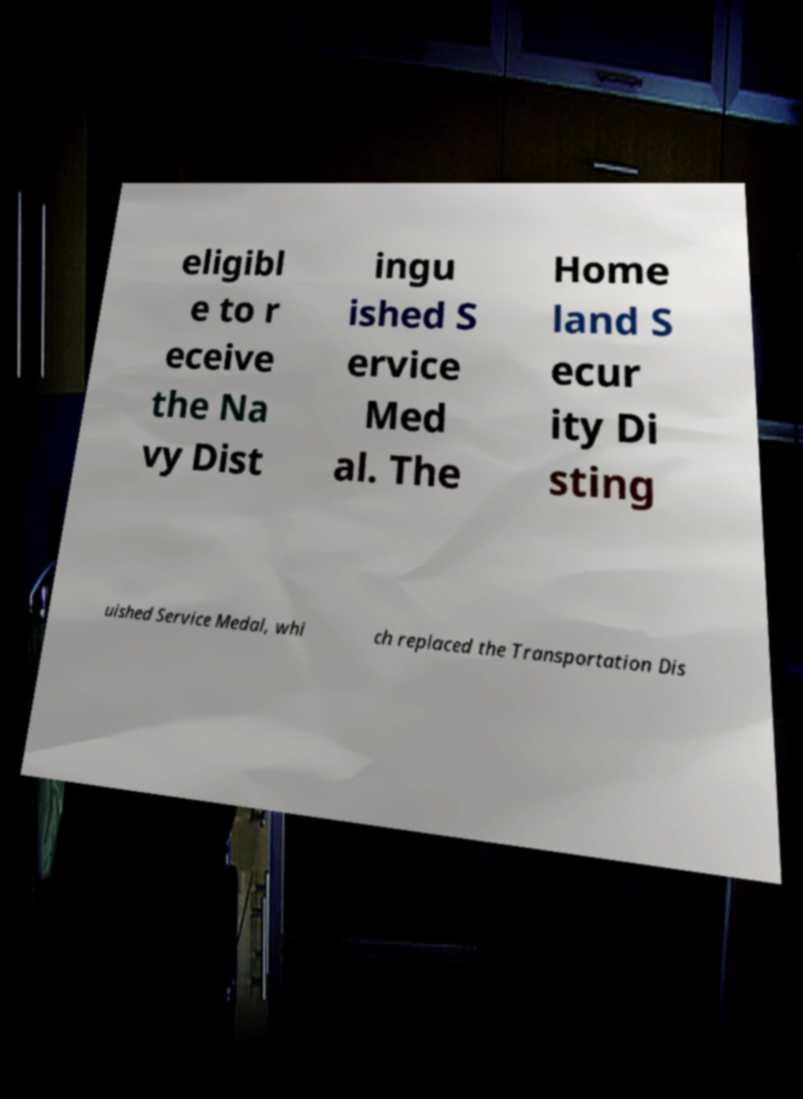Can you accurately transcribe the text from the provided image for me? eligibl e to r eceive the Na vy Dist ingu ished S ervice Med al. The Home land S ecur ity Di sting uished Service Medal, whi ch replaced the Transportation Dis 